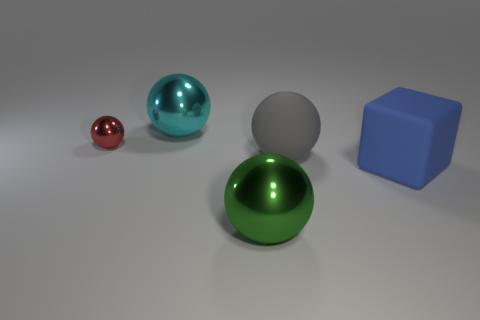Does the block have the same material as the cyan object behind the red ball?
Your answer should be very brief. No. The big thing that is in front of the gray sphere and behind the big green ball has what shape?
Ensure brevity in your answer.  Cube. What number of other things are the same color as the big rubber cube?
Give a very brief answer. 0. There is a big green object; what shape is it?
Offer a terse response. Sphere. What color is the object on the left side of the large sphere that is on the left side of the green shiny ball?
Ensure brevity in your answer.  Red. What material is the large object that is right of the large green ball and to the left of the large blue rubber cube?
Make the answer very short. Rubber. Are there any blue objects of the same size as the cyan thing?
Give a very brief answer. Yes. There is a blue block that is the same size as the gray ball; what is it made of?
Offer a terse response. Rubber. There is a big cyan thing; how many gray balls are in front of it?
Your answer should be compact. 1. There is a big shiny thing that is behind the small shiny ball; is it the same shape as the tiny shiny thing?
Provide a succinct answer. Yes. 